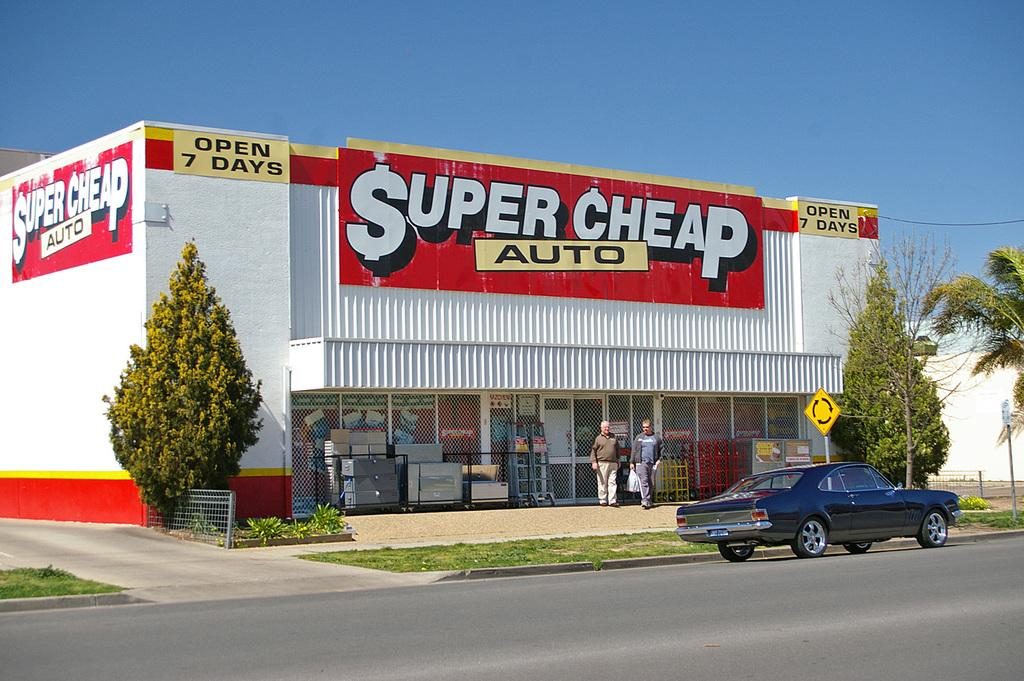What is on the road in the image? There is a car on the road in the image. What can be seen in the background of the image? There are trees and a building in the image. What are the two people in the image doing? The two people are standing. How many mice can be seen sneezing while playing an instrument in the image? There are no mice, sneezing, or instruments present in the image. 